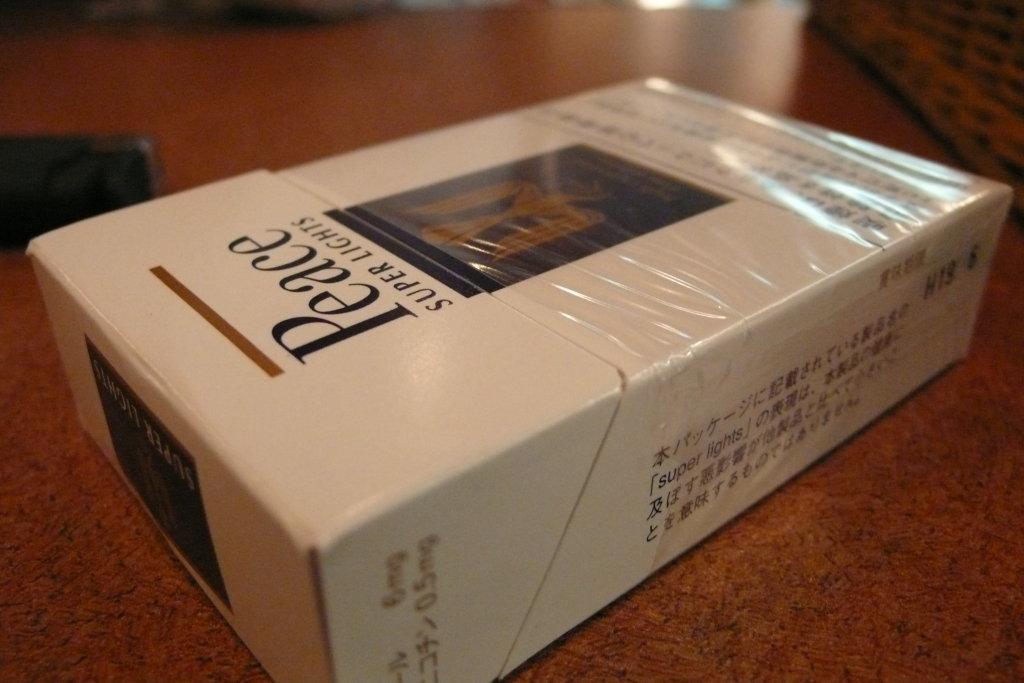What brand of cigarettes are these?
Give a very brief answer. Peace. 